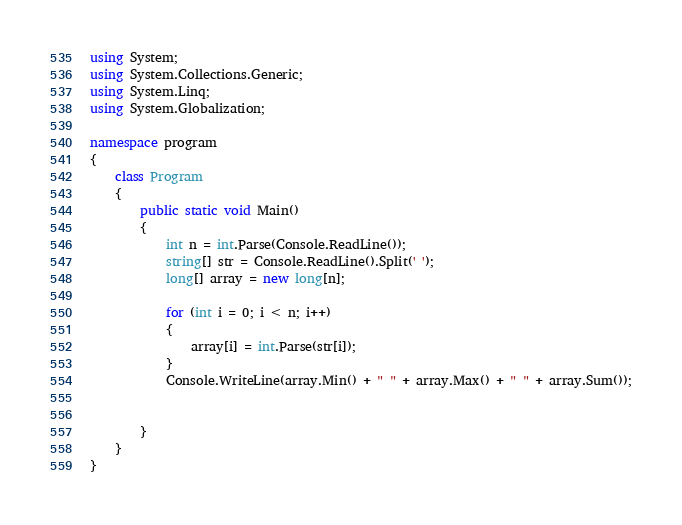Convert code to text. <code><loc_0><loc_0><loc_500><loc_500><_C#_>using System;
using System.Collections.Generic;
using System.Linq;
using System.Globalization;

namespace program
{
    class Program
    {
        public static void Main()
        {
            int n = int.Parse(Console.ReadLine());
            string[] str = Console.ReadLine().Split(' ');
            long[] array = new long[n];

            for (int i = 0; i < n; i++)
            {
                array[i] = int.Parse(str[i]);
            }
            Console.WriteLine(array.Min() + " " + array.Max() + " " + array.Sum());
            

        }
    }
}
</code> 